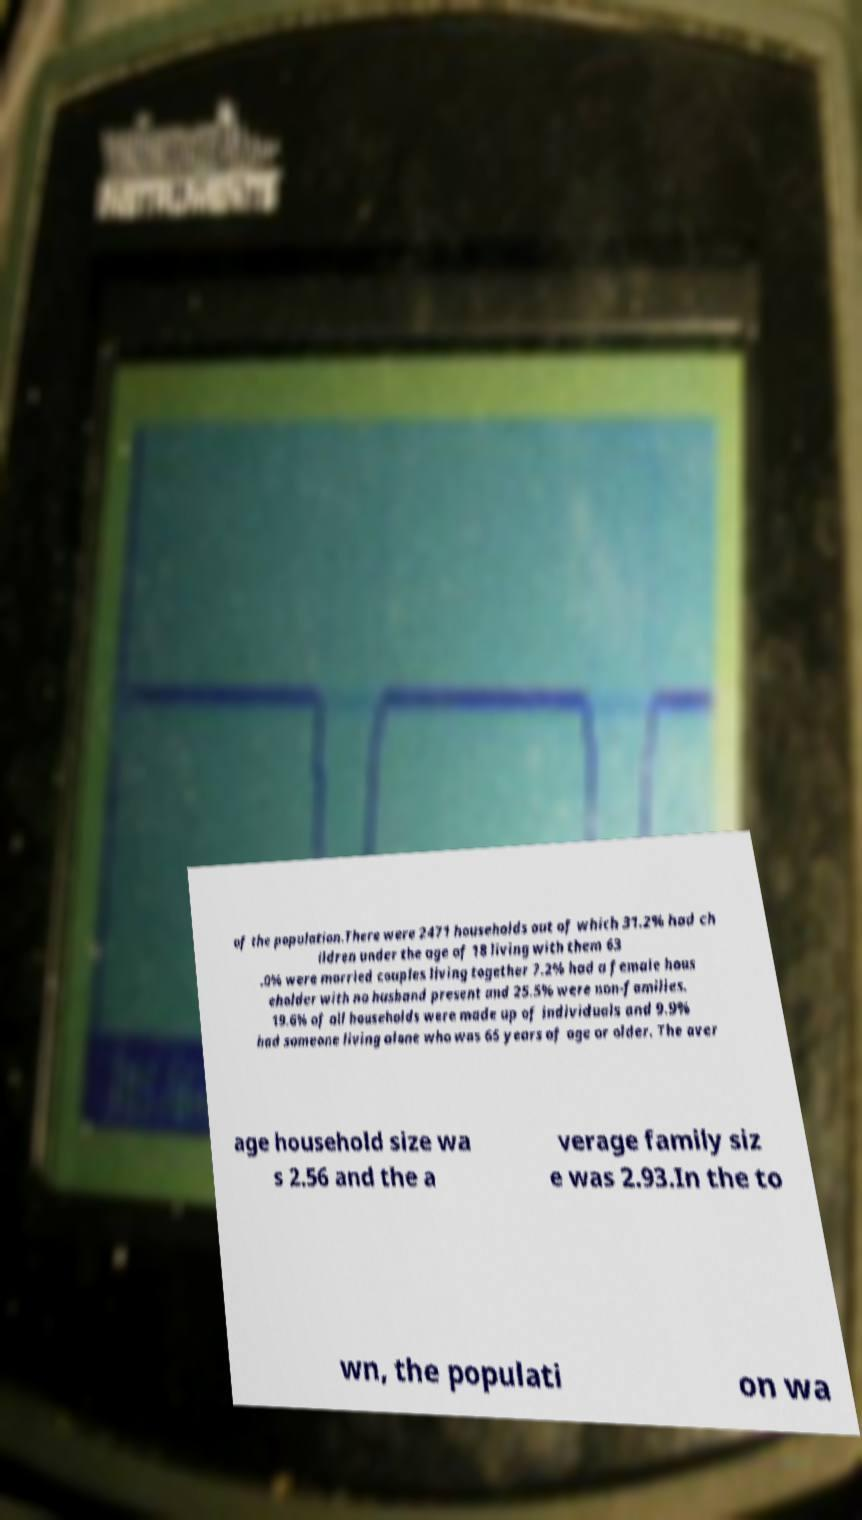Can you accurately transcribe the text from the provided image for me? of the population.There were 2471 households out of which 31.2% had ch ildren under the age of 18 living with them 63 .0% were married couples living together 7.2% had a female hous eholder with no husband present and 25.5% were non-families. 19.6% of all households were made up of individuals and 9.9% had someone living alone who was 65 years of age or older. The aver age household size wa s 2.56 and the a verage family siz e was 2.93.In the to wn, the populati on wa 